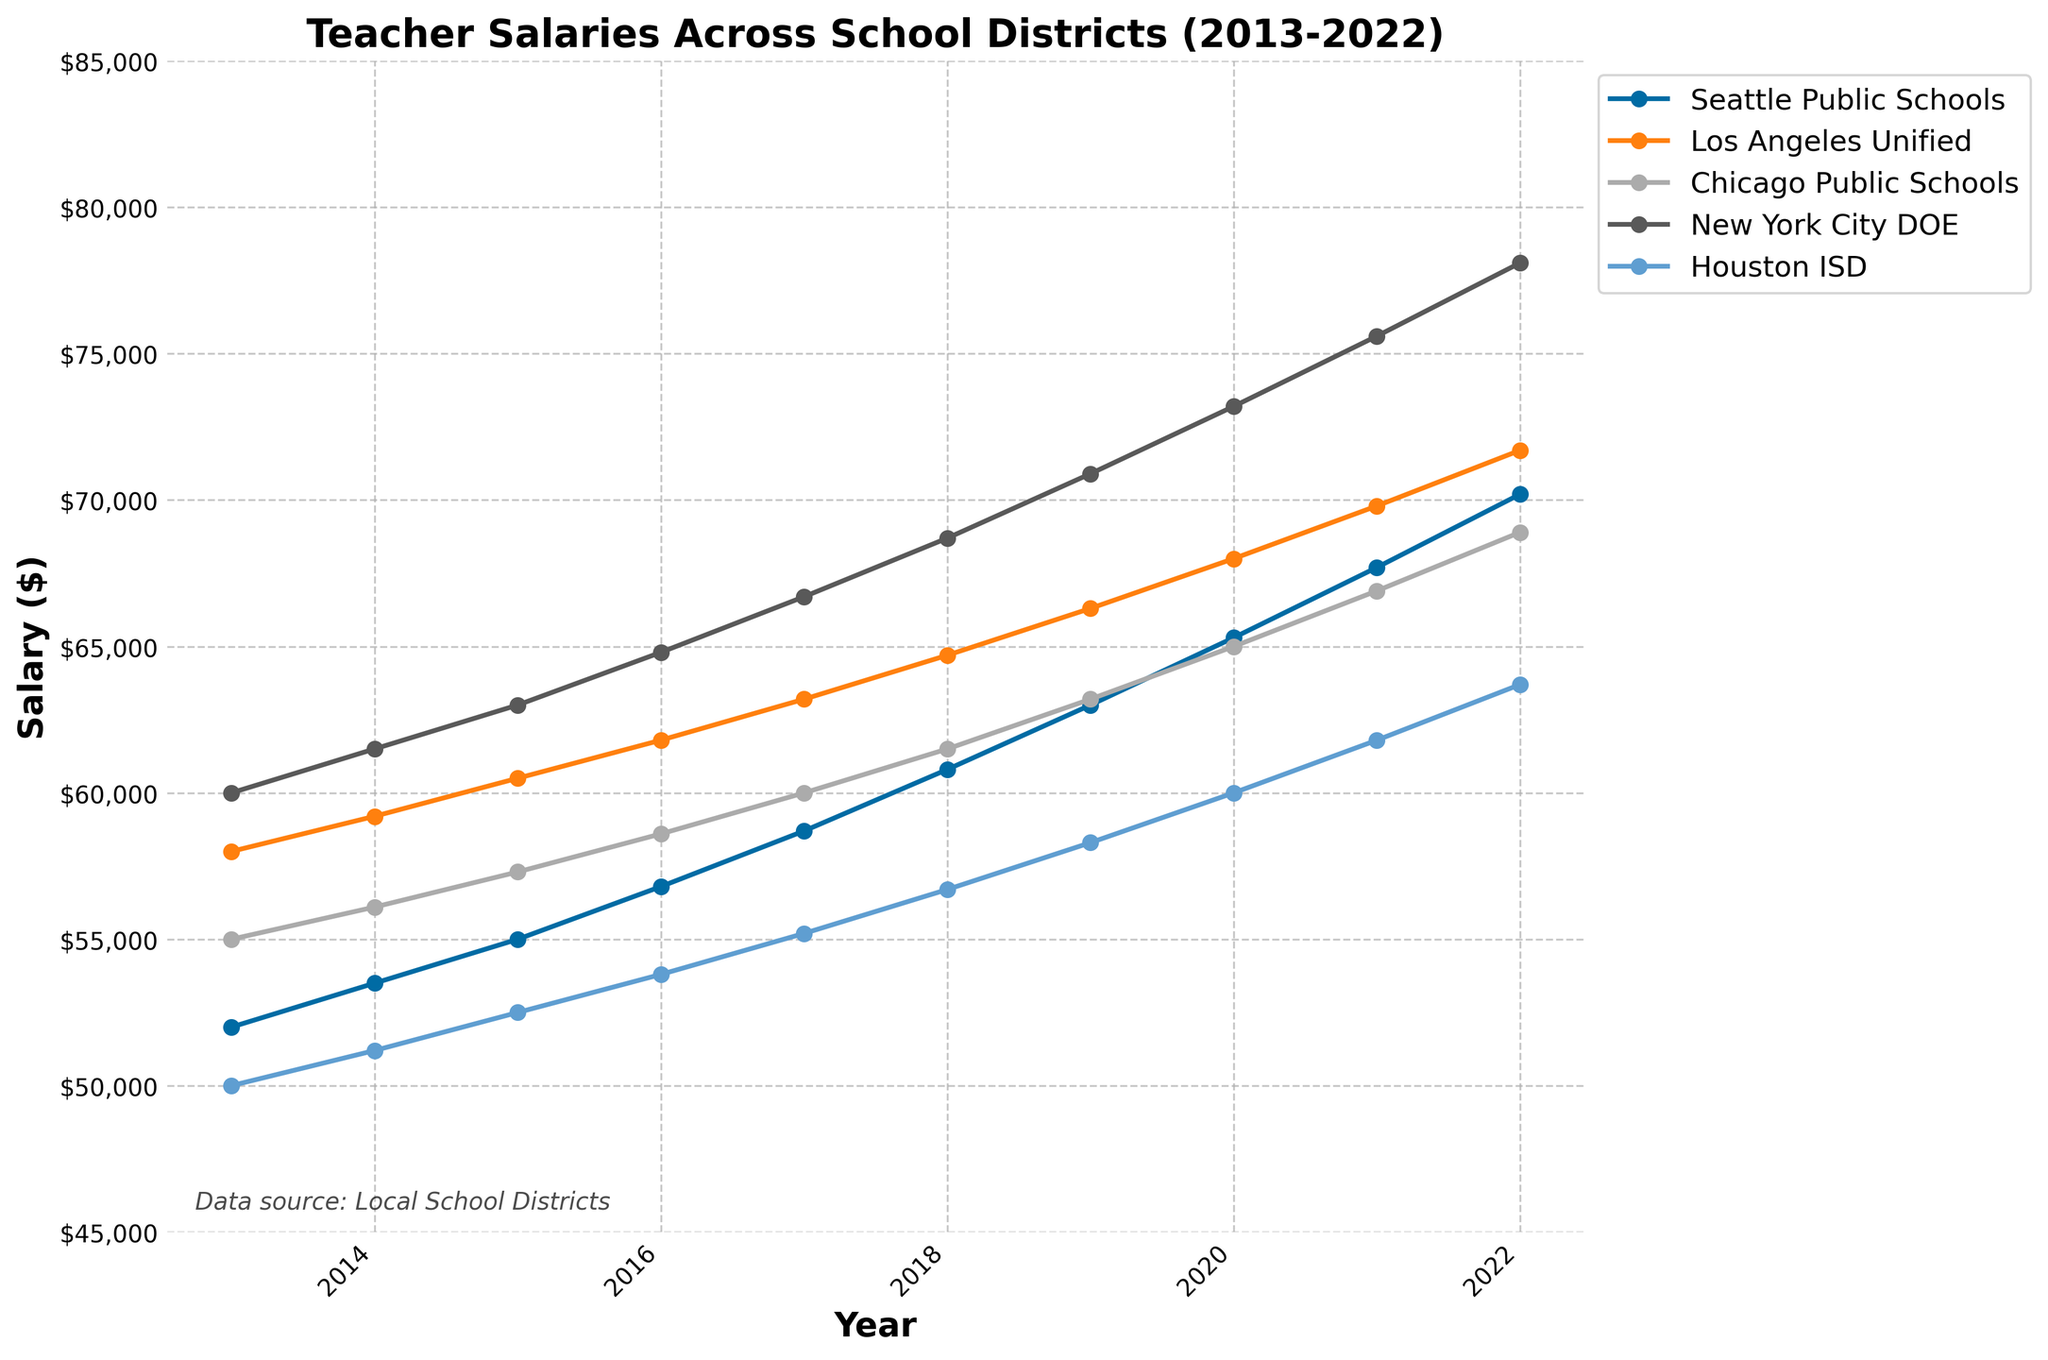How has the salary trend for Seattle Public Schools changed over the decade? The salary for Seattle Public Schools has shown an upward trend from $52,000 in 2013 to $70,200 in 2022.
Answer: Upward trend Which school district had the highest salary in 2022? New York City DOE had the highest salary in 2022 at $78,100.
Answer: New York City DOE What is the difference in salaries between Los Angeles Unified and Houston ISD in 2020? In 2020, Los Angeles Unified had a salary of $68,000, and Houston ISD had a salary of $60,000. The difference is $68,000 - $60,000 = $8,000.
Answer: $8,000 Which school district has the most consistent salary increase over the years? By looking at the lines, Seattle Public Schools seems to have the most consistent increase, with salaries rising steadily each year without any significant drops or unusual fluctuations.
Answer: Seattle Public Schools What is the average teacher salary for Chicago Public Schools across the years 2015 to 2017? The salaries for Chicago Public Schools from 2015 to 2017 are $57,300, $58,600, and $60,000. The average is ($57,300 + $58,600 + $60,000) / 3 = $58,633.33.
Answer: $58,633.33 How does the salary growth rate in New York City DOE from 2018 to 2022 compare to that of Los Angeles Unified in the same period? For New York City DOE, the salaries from 2018 to 2022 are $68,700, $70,900, $73,200, $75,600, and $78,100, making an increase of $78,100 - $68,700 = $9,400. For Los Angeles Unified, the salaries are $64,700, $66,300, $68,000, $69,800, and $71,700, making an increase of $71,700 - $64,700 = $7,000. New York City DOE has a higher growth rate.
Answer: New York City DOE In which year did Houston ISD and Seattle Public Schools have the same salary, if at all? Both districts had the same salary in none of the years shown.
Answer: None What is the total salary increase for Chicago Public Schools from 2013 to 2022? Chicago Public Schools' salary increased from $55,000 in 2013 to $68,900 in 2022. Therefore, the total increase is $68,900 - $55,000 = $13,900.
Answer: $13,900 